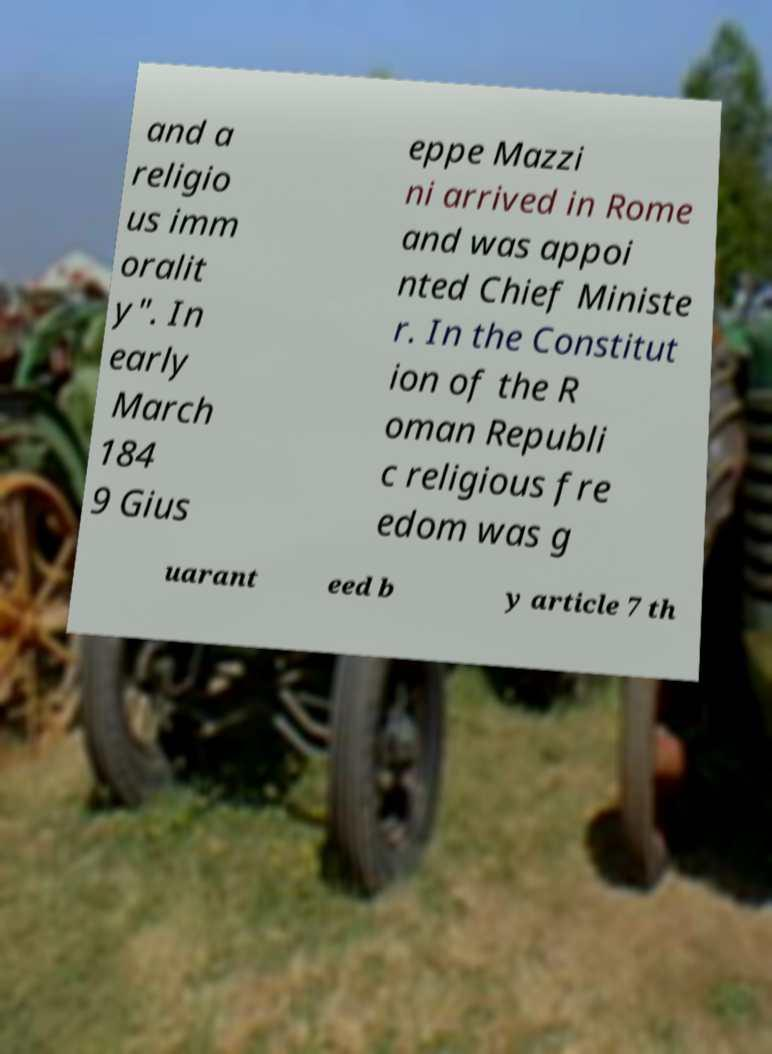Can you read and provide the text displayed in the image?This photo seems to have some interesting text. Can you extract and type it out for me? and a religio us imm oralit y". In early March 184 9 Gius eppe Mazzi ni arrived in Rome and was appoi nted Chief Ministe r. In the Constitut ion of the R oman Republi c religious fre edom was g uarant eed b y article 7 th 